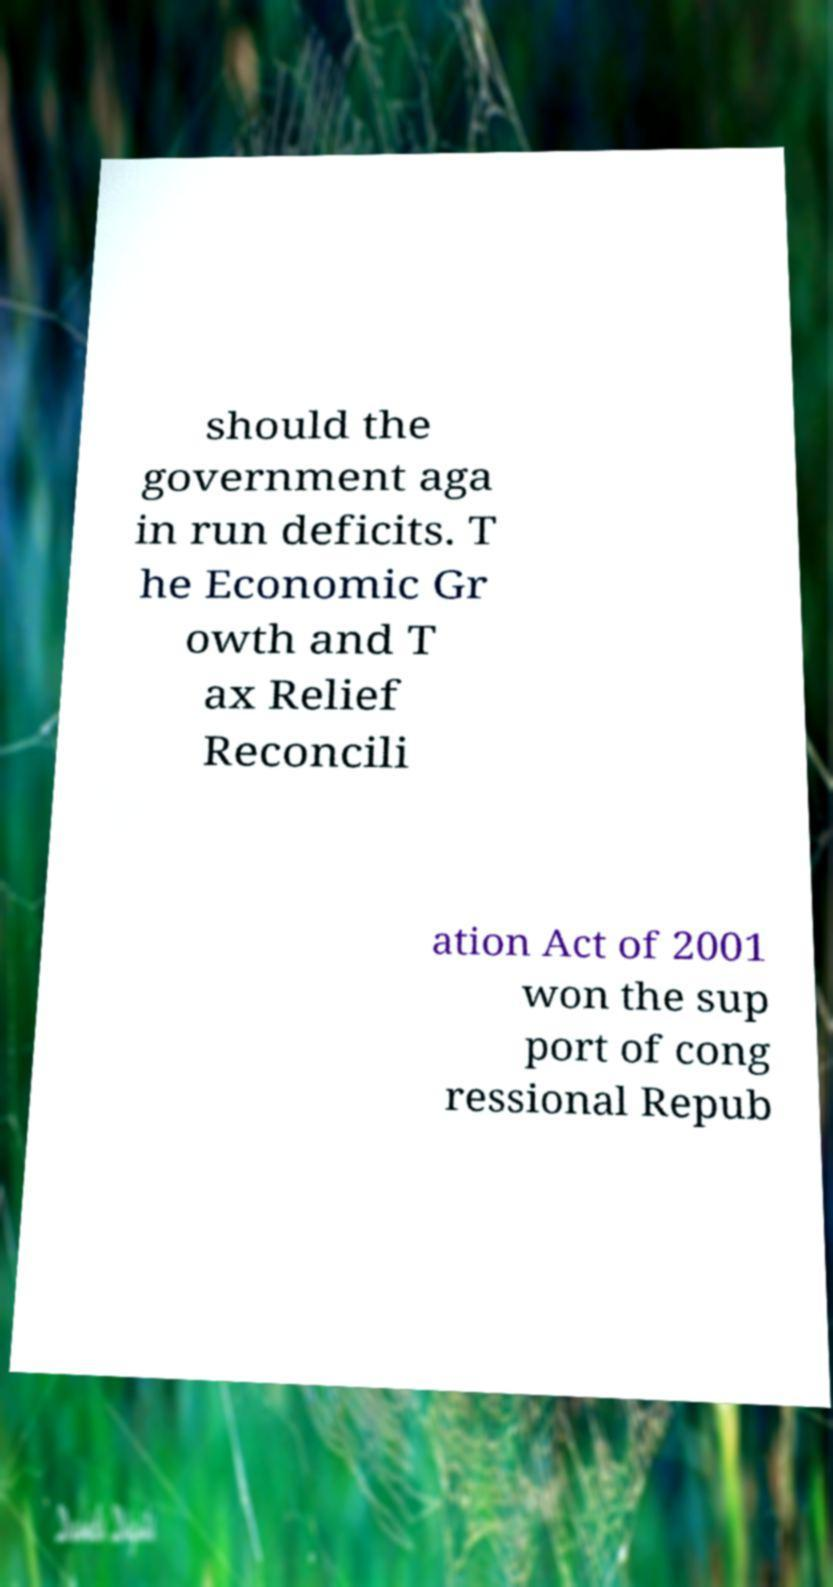I need the written content from this picture converted into text. Can you do that? should the government aga in run deficits. T he Economic Gr owth and T ax Relief Reconcili ation Act of 2001 won the sup port of cong ressional Repub 